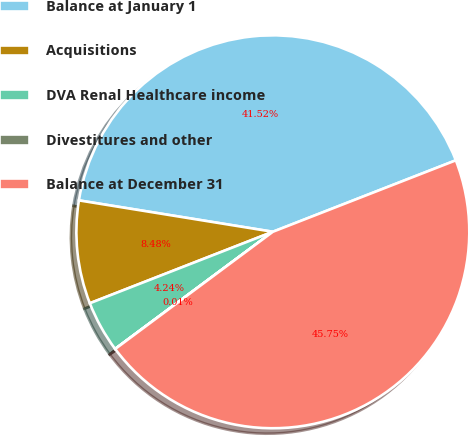Convert chart to OTSL. <chart><loc_0><loc_0><loc_500><loc_500><pie_chart><fcel>Balance at January 1<fcel>Acquisitions<fcel>DVA Renal Healthcare income<fcel>Divestitures and other<fcel>Balance at December 31<nl><fcel>41.52%<fcel>8.48%<fcel>4.24%<fcel>0.01%<fcel>45.75%<nl></chart> 